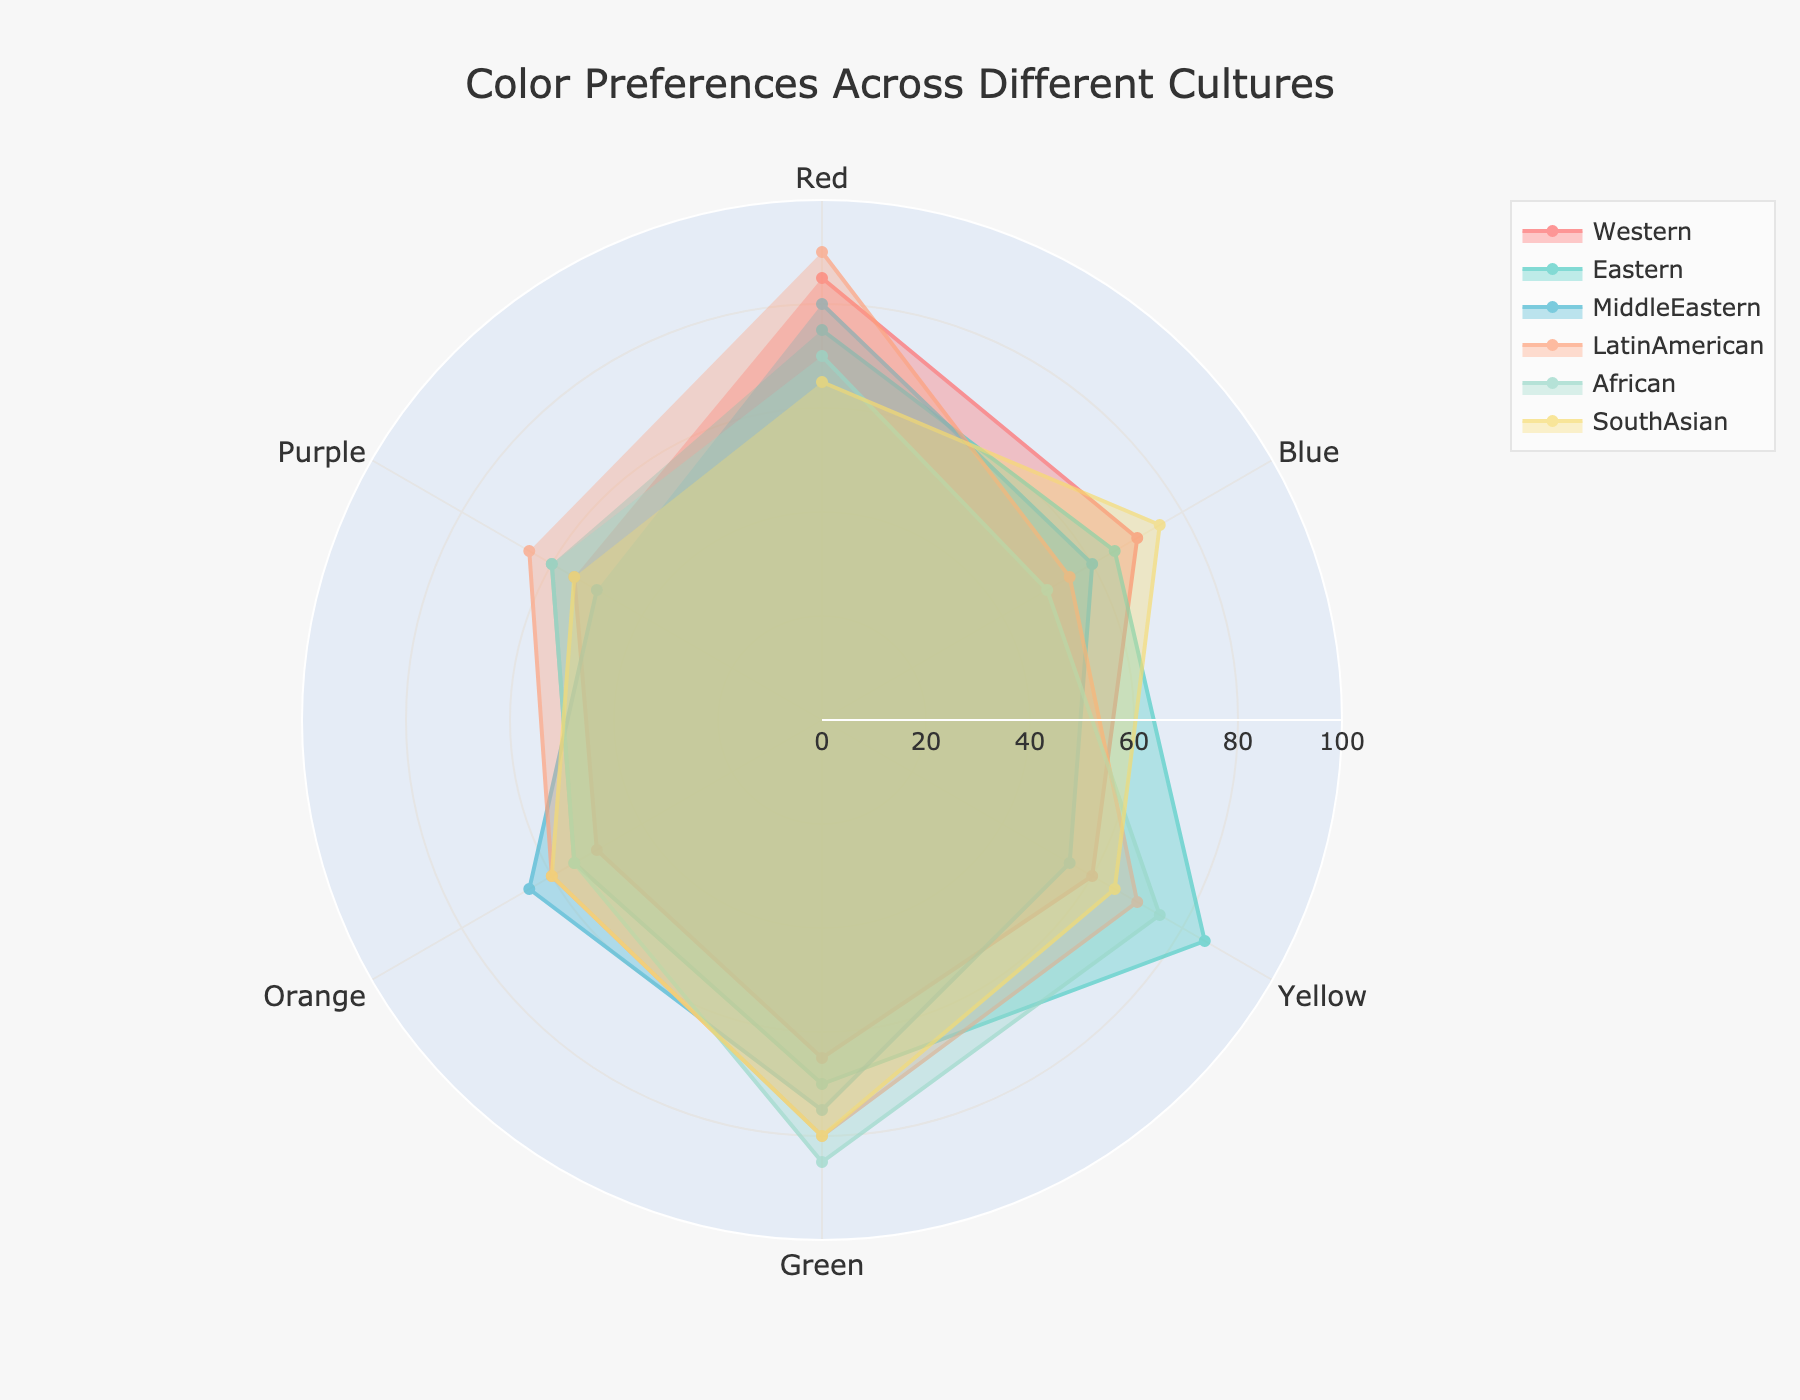1. What is the title of the radar chart? The title of a chart is typically found at the top. In this radar chart, the title is "Color Preferences Across Different Cultures."
Answer: Color Preferences Across Different Cultures 2. Which culture shows the highest preference for the color green? To find this, look at the values for green in each culture. The culture with the highest value/preference is LatinAmerican with a value of 80.
Answer: LatinAmerican 3. Which two cultures have the closest preference values for the color blue? Comparing the values for blue: Western (70), Eastern (65), MiddleEastern (60), LatinAmerican (55), African (50), and SouthAsian (75). The closest are Western (70) and Eastern (65). To confirm, the difference between these values is 70 - 65 = 5, which is the smallest gap.
Answer: Western and Eastern 4. What is the average preference value for orange across all cultures? First, sum the values for orange: 50 (Western) + 55 (Eastern) + 65 (MiddleEastern) + 60 (LatinAmerican) + 55 (African) + 60 (SouthAsian) = 345. Then, divide by the number of cultures (6): 345 / 6 = 57.5.
Answer: 57.5 5. Which culture has the most balanced preference among all colors (smallest variance)? Calculate the variance for each culture's preferences. Lower variance means more balanced. Calculations show Eastern culture has the smallest variance in its color preferences (where values range between 55-85).
Answer: Eastern 6. Which color is least preferred in the African culture? Review African culture's values for all colors: Red (70), Blue (50), Yellow (75), Green (85), Orange (55), and Purple (60). The least preferred color is Blue, with a value of 50.
Answer: Blue 7. Compare the preference for Purple between LatinAmerican and MiddleEastern cultures. Which is higher? LatinAmerican has a preference value of 65 for Purple, whereas MiddleEastern has a value of 50. LatinAmerican's preference is higher.
Answer: LatinAmerican 8. Sum the preference scores for primary colors (Red, Blue, Yellow) in SouthAsian culture. The values for SouthAsian culture are Red (65), Blue (75), Yellow (65). Sum them: 65 + 75 + 65 = 205.
Answer: 205 9. Which culture has the lowest preference for Yellow? Reviewing Yellow values: Western (60), Eastern (85), MiddleEastern (55), LatinAmerican (70), African (75), SouthAsian (65). The MiddleEastern culture has the lowest preference at 55.
Answer: MiddleEastern 10. For the Western culture, what is the percentage preference for Green compared to the total preferences for all colors? First, sum Western culture's color preferences: 85 (Red) + 70 (Blue) + 60 (Yellow) + 65 (Green) + 50 (Orange) + 55 (Purple) = 385. Then, find the percentage of Green: (65 / 385) * 100 ≈ 16.88%.
Answer: ≈16.88% 